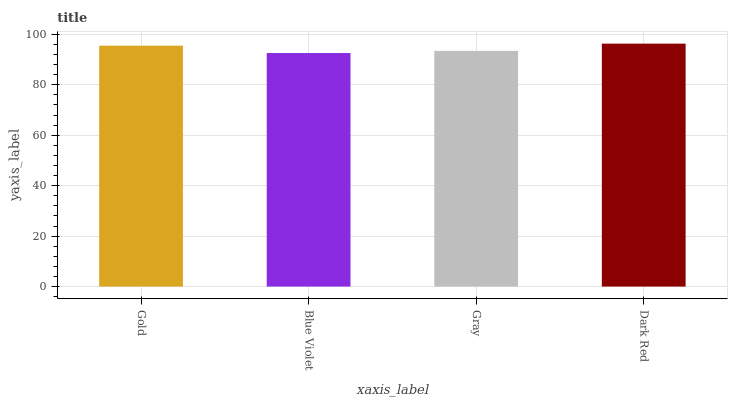Is Blue Violet the minimum?
Answer yes or no. Yes. Is Dark Red the maximum?
Answer yes or no. Yes. Is Gray the minimum?
Answer yes or no. No. Is Gray the maximum?
Answer yes or no. No. Is Gray greater than Blue Violet?
Answer yes or no. Yes. Is Blue Violet less than Gray?
Answer yes or no. Yes. Is Blue Violet greater than Gray?
Answer yes or no. No. Is Gray less than Blue Violet?
Answer yes or no. No. Is Gold the high median?
Answer yes or no. Yes. Is Gray the low median?
Answer yes or no. Yes. Is Blue Violet the high median?
Answer yes or no. No. Is Gold the low median?
Answer yes or no. No. 